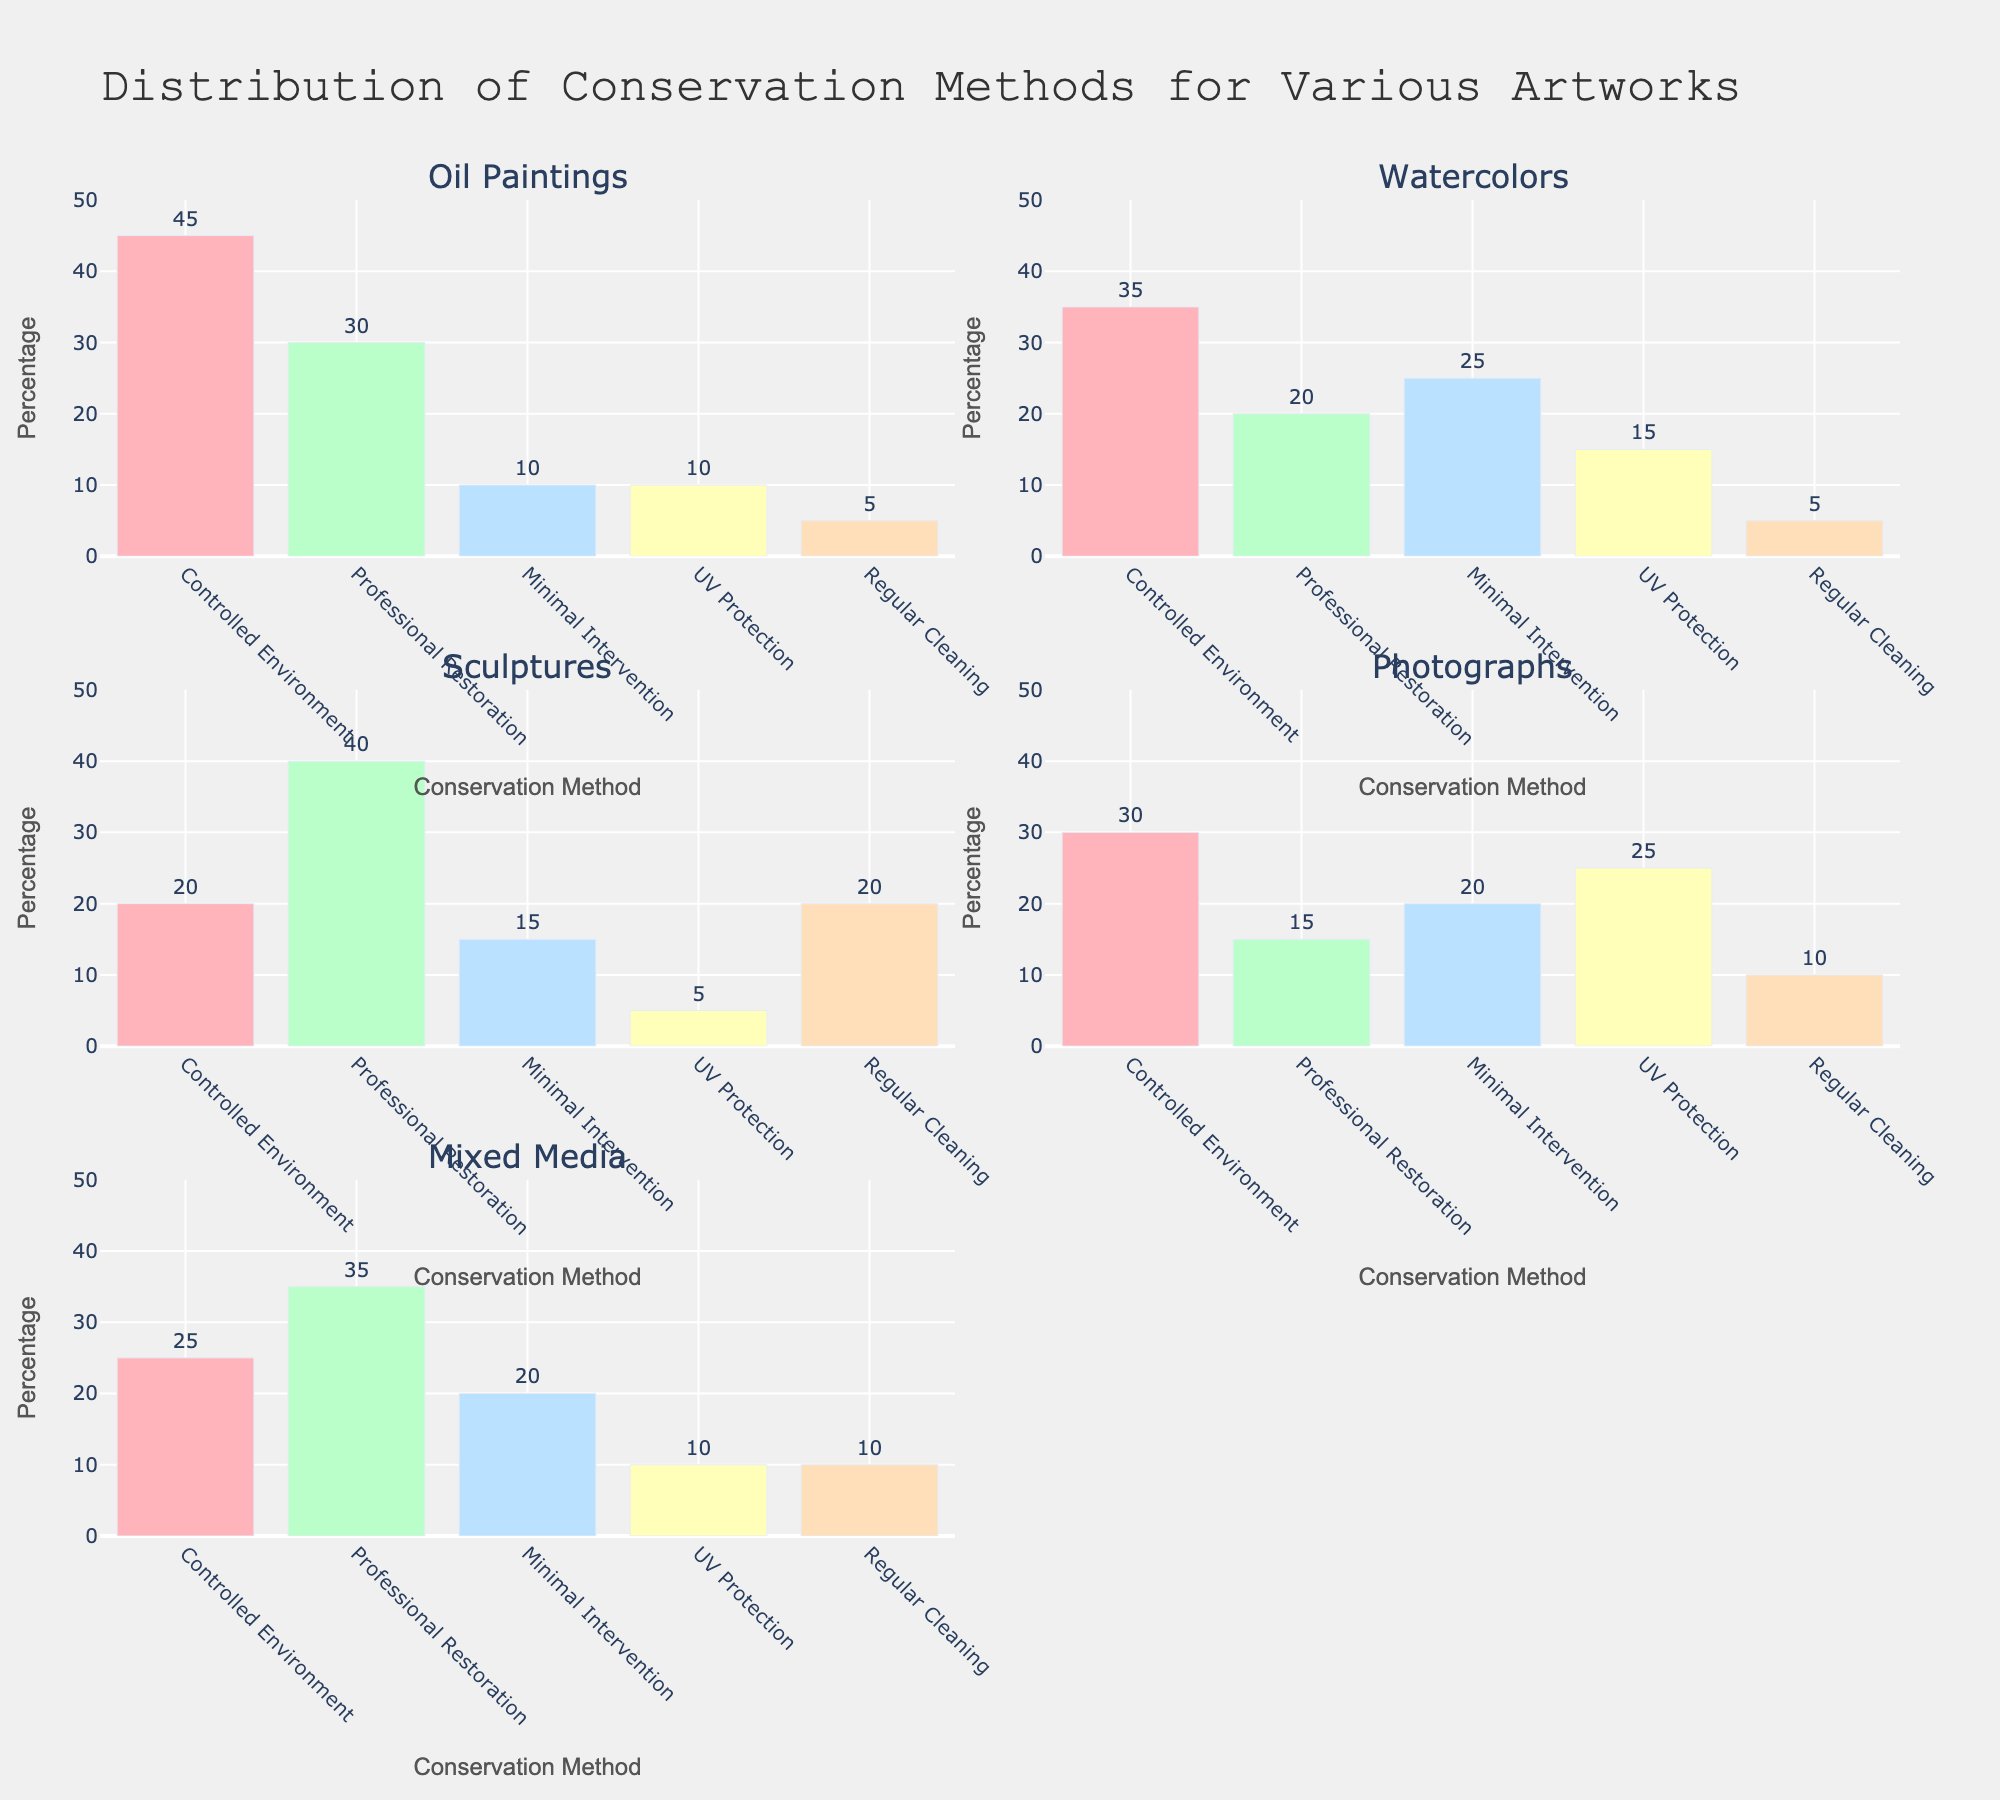what is the title of the figure? The title is located at the top of the figure. It is "Distribution of Conservation Methods for Various Artworks."
Answer: Distribution of Conservation Methods for Various Artworks What is the most preferred conservation method for oil paintings? To find this, look at the subplot titled "Oil Paintings" and identify the tallest bar. The tallest bar corresponds to "Controlled Environment" with a height of 45%.
Answer: Controlled Environment What are the least preferred conservation methods for sculptures and mixed media? Examine the subplots "Sculptures" and "Mixed Media" and find the shortest bars in each. For "Sculptures," the shortest bar corresponds to "UV Protection" with 5%. For "Mixed Media," the shortest bars are "UV Protection" and "Regular Cleaning," both with 10%.
Answer: UV Protection and UV Protection/Regular Cleaning Which artwork type has the highest percentage for professional restoration? Check each subplot for the height of the bar corresponding to "Professional Restoration." The highest value is found in "Sculptures" with 40%.
Answer: Sculptures Among watercolors and photographs, which artwork type has a higher preference for minimal intervention? Compare the bars for "Minimal Intervention" in the subplots "Watercolors" and "Photographs." "Watercolors" has a higher preference with 25%, compared to 20% for "Photographs."
Answer: Watercolors What is the average percentage of UV Protection across all artwork types? Sum the percentages for "UV Protection" across all subplots: (10+15+5+25+10) = 65. There are 5 artwork types, so divide by 5: 65/5 = 13.
Answer: 13 Is there any artwork type where the percentage for regular cleaning is exactly 5%? Look at the bars corresponding to "Regular Cleaning" for all subplots. "Oil Paintings" and "Watercolors" both have a "Regular Cleaning" percentage of 5%.
Answer: Yes, Oil Paintings and Watercolors Which conservation method has the lowest maximum percentage across all artwork types? Identify the highest value for each method across all subplots: Controlled Environment (45), Professional Restoration (40), Minimal Intervention (25), UV Protection (25), Regular Cleaning (20). The lowest maximum percentage is for "Regular Cleaning" with 20%.
Answer: Regular Cleaning 